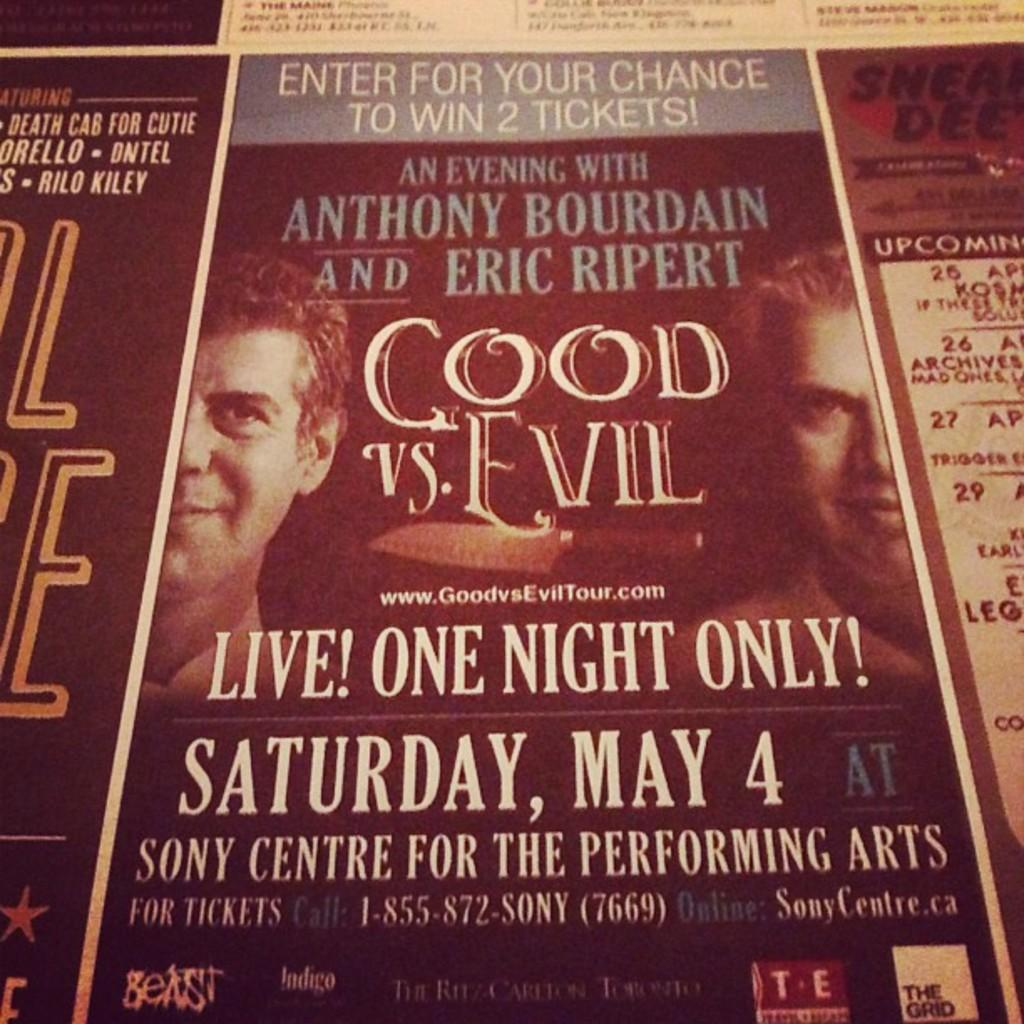<image>
Write a terse but informative summary of the picture. A poster for Cool Vs. Evil, An Evening with Anthony Bourdain and Eric Ripert. 